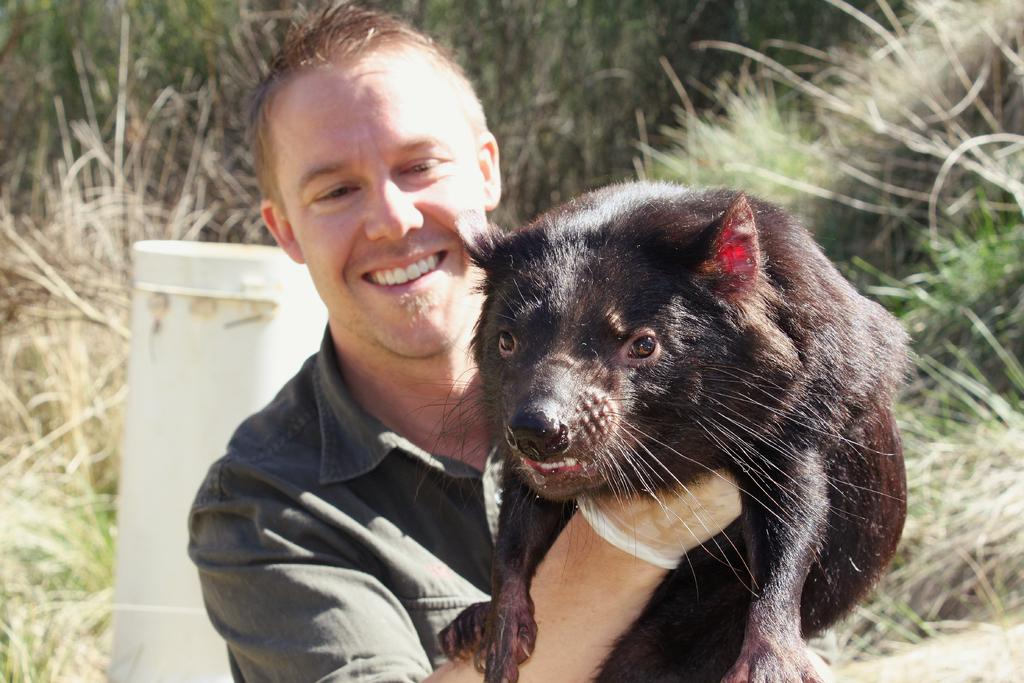What is present in the image? There is a person in the image. What is the person holding? The person is holding a black color animal. What can be seen in the background of the image? There is greenery grass in the background of the image. What word is written on the leaf in the image? There is no leaf or word present in the image. How does the person's stomach feel while holding the animal? The provided facts do not mention anything about the person's stomach, so we cannot determine how they feel while holding the animal. 